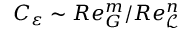Convert formula to latex. <formula><loc_0><loc_0><loc_500><loc_500>C _ { \varepsilon } \sim R e _ { G } ^ { m } / R e _ { \mathcal { L } } ^ { n }</formula> 